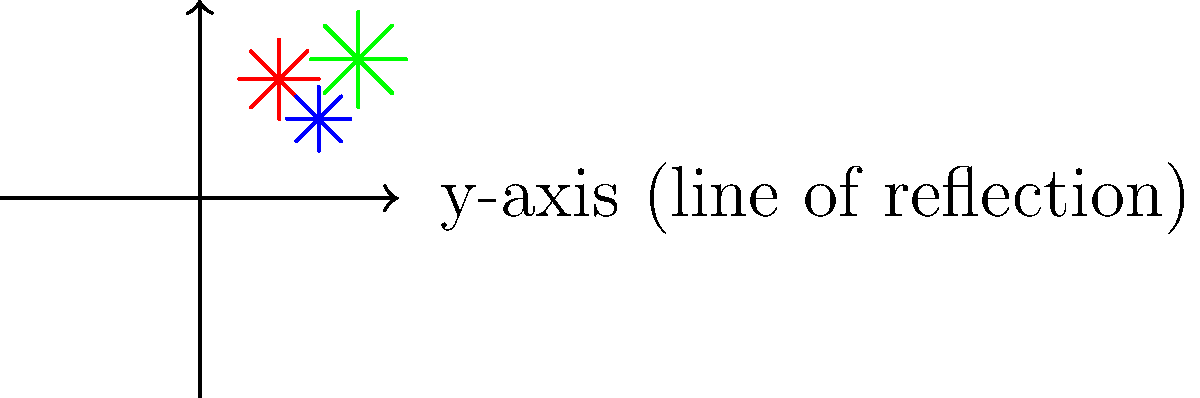A festival organizer wants to create a symmetrical fireworks display for better viewing from both sides of a river. The current design is shown in the image, with the y-axis representing the river (line of reflection). If the organizer wants to reflect the entire design across the y-axis, what will be the coordinates of the blue firework after reflection? To solve this problem, we need to understand the concept of reflection across the y-axis:

1. Identify the original coordinates of the blue firework: (3, 2)

2. Recall the rule for reflecting a point (x, y) across the y-axis:
   The reflected point will be (-x, y)

3. Apply the reflection rule to the blue firework's coordinates:
   Original: (3, 2)
   Reflected: (-3, 2)

4. Verify: The x-coordinate changes sign, while the y-coordinate remains the same.

5. In the context of the festival, this means the blue firework will be placed at the same height above the river (y = 2) but on the opposite side, 3 units away from the river.
Answer: (-3, 2) 